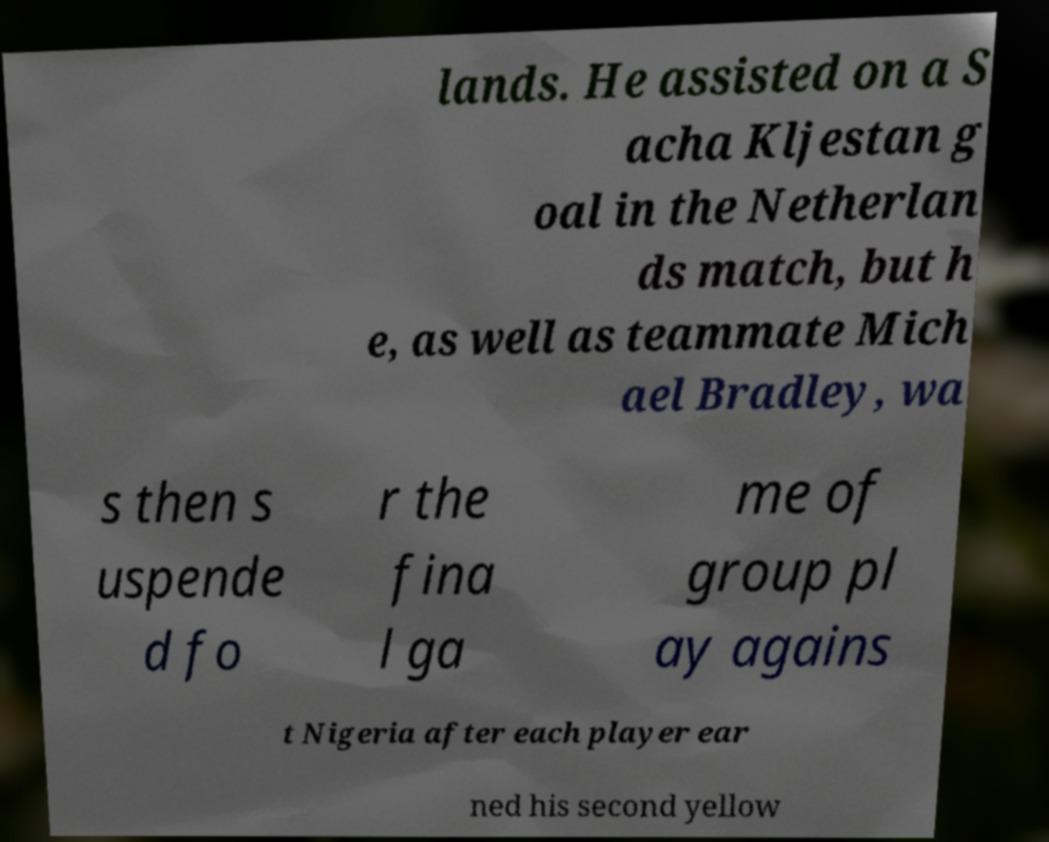Can you accurately transcribe the text from the provided image for me? lands. He assisted on a S acha Kljestan g oal in the Netherlan ds match, but h e, as well as teammate Mich ael Bradley, wa s then s uspende d fo r the fina l ga me of group pl ay agains t Nigeria after each player ear ned his second yellow 